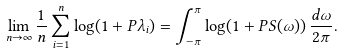<formula> <loc_0><loc_0><loc_500><loc_500>\lim _ { n \to \infty } \frac { 1 } { n } \sum _ { i = 1 } ^ { n } \log ( 1 + P \lambda _ { i } ) = \int _ { - \pi } ^ { \pi } \log ( 1 + P S ( \omega ) ) \, \frac { d \omega } { 2 \pi } .</formula> 